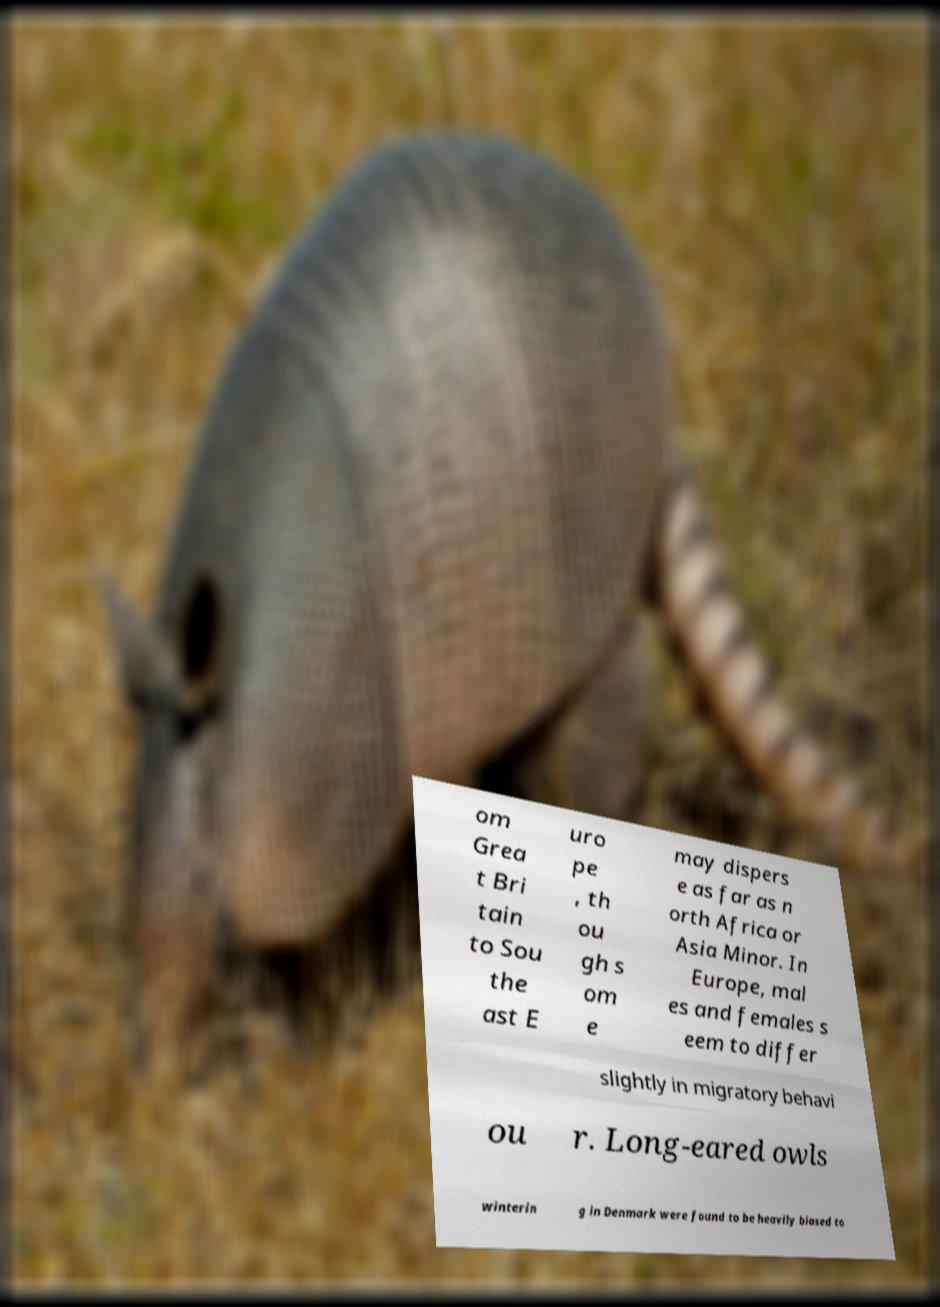Can you read and provide the text displayed in the image?This photo seems to have some interesting text. Can you extract and type it out for me? om Grea t Bri tain to Sou the ast E uro pe , th ou gh s om e may dispers e as far as n orth Africa or Asia Minor. In Europe, mal es and females s eem to differ slightly in migratory behavi ou r. Long-eared owls winterin g in Denmark were found to be heavily biased to 